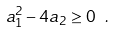<formula> <loc_0><loc_0><loc_500><loc_500>a _ { 1 } ^ { 2 } - 4 a _ { 2 } \geq 0 \ .</formula> 